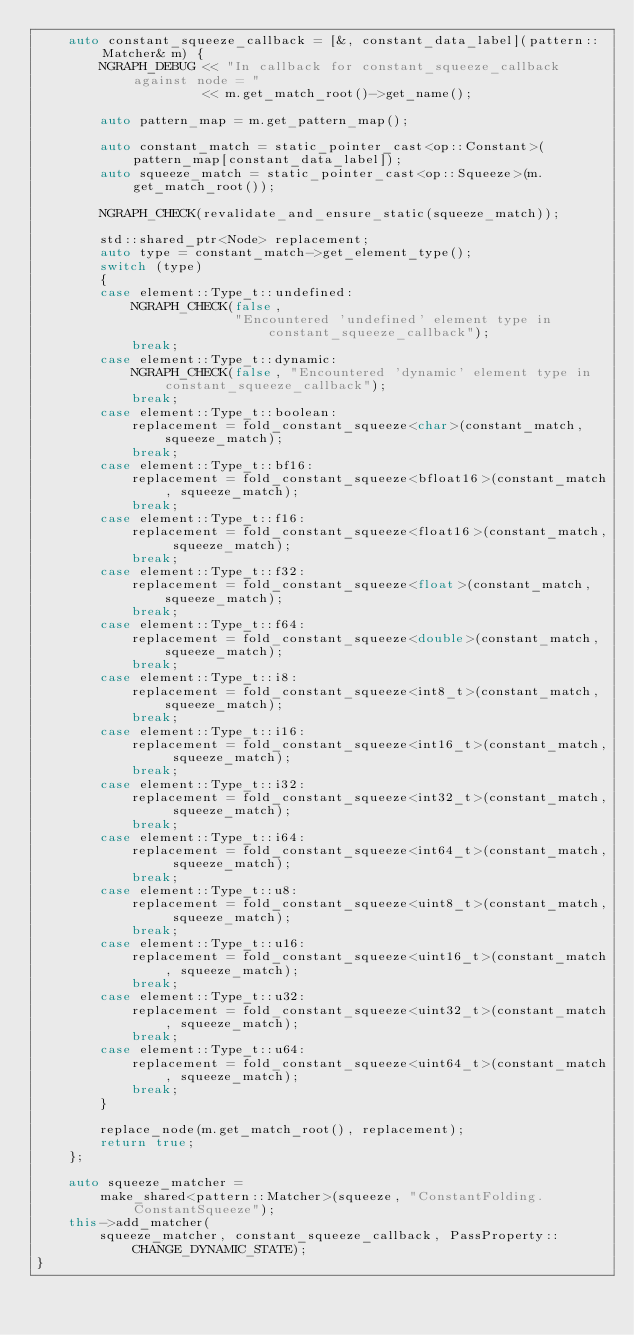<code> <loc_0><loc_0><loc_500><loc_500><_C++_>    auto constant_squeeze_callback = [&, constant_data_label](pattern::Matcher& m) {
        NGRAPH_DEBUG << "In callback for constant_squeeze_callback against node = "
                     << m.get_match_root()->get_name();

        auto pattern_map = m.get_pattern_map();

        auto constant_match = static_pointer_cast<op::Constant>(pattern_map[constant_data_label]);
        auto squeeze_match = static_pointer_cast<op::Squeeze>(m.get_match_root());

        NGRAPH_CHECK(revalidate_and_ensure_static(squeeze_match));

        std::shared_ptr<Node> replacement;
        auto type = constant_match->get_element_type();
        switch (type)
        {
        case element::Type_t::undefined:
            NGRAPH_CHECK(false,
                         "Encountered 'undefined' element type in constant_squeeze_callback");
            break;
        case element::Type_t::dynamic:
            NGRAPH_CHECK(false, "Encountered 'dynamic' element type in constant_squeeze_callback");
            break;
        case element::Type_t::boolean:
            replacement = fold_constant_squeeze<char>(constant_match, squeeze_match);
            break;
        case element::Type_t::bf16:
            replacement = fold_constant_squeeze<bfloat16>(constant_match, squeeze_match);
            break;
        case element::Type_t::f16:
            replacement = fold_constant_squeeze<float16>(constant_match, squeeze_match);
            break;
        case element::Type_t::f32:
            replacement = fold_constant_squeeze<float>(constant_match, squeeze_match);
            break;
        case element::Type_t::f64:
            replacement = fold_constant_squeeze<double>(constant_match, squeeze_match);
            break;
        case element::Type_t::i8:
            replacement = fold_constant_squeeze<int8_t>(constant_match, squeeze_match);
            break;
        case element::Type_t::i16:
            replacement = fold_constant_squeeze<int16_t>(constant_match, squeeze_match);
            break;
        case element::Type_t::i32:
            replacement = fold_constant_squeeze<int32_t>(constant_match, squeeze_match);
            break;
        case element::Type_t::i64:
            replacement = fold_constant_squeeze<int64_t>(constant_match, squeeze_match);
            break;
        case element::Type_t::u8:
            replacement = fold_constant_squeeze<uint8_t>(constant_match, squeeze_match);
            break;
        case element::Type_t::u16:
            replacement = fold_constant_squeeze<uint16_t>(constant_match, squeeze_match);
            break;
        case element::Type_t::u32:
            replacement = fold_constant_squeeze<uint32_t>(constant_match, squeeze_match);
            break;
        case element::Type_t::u64:
            replacement = fold_constant_squeeze<uint64_t>(constant_match, squeeze_match);
            break;
        }

        replace_node(m.get_match_root(), replacement);
        return true;
    };

    auto squeeze_matcher =
        make_shared<pattern::Matcher>(squeeze, "ConstantFolding.ConstantSqueeze");
    this->add_matcher(
        squeeze_matcher, constant_squeeze_callback, PassProperty::CHANGE_DYNAMIC_STATE);
}
</code> 